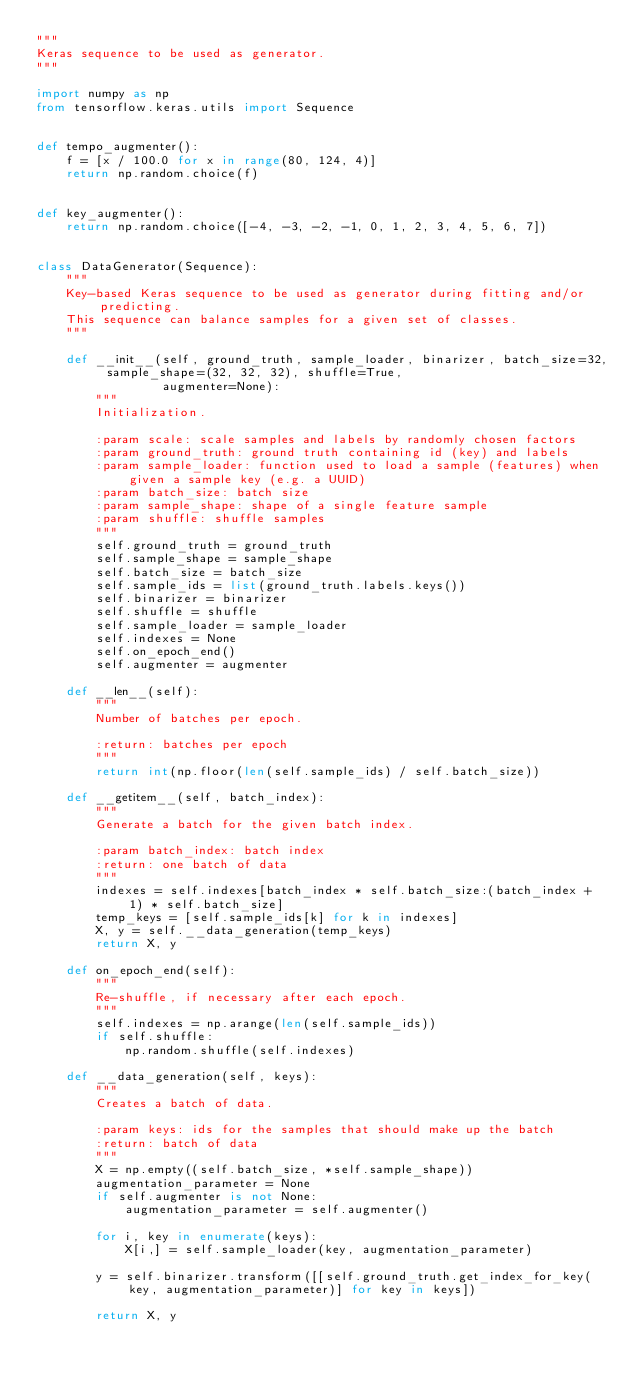<code> <loc_0><loc_0><loc_500><loc_500><_Python_>"""
Keras sequence to be used as generator.
"""

import numpy as np
from tensorflow.keras.utils import Sequence


def tempo_augmenter():
    f = [x / 100.0 for x in range(80, 124, 4)]
    return np.random.choice(f)


def key_augmenter():
    return np.random.choice([-4, -3, -2, -1, 0, 1, 2, 3, 4, 5, 6, 7])


class DataGenerator(Sequence):
    """
    Key-based Keras sequence to be used as generator during fitting and/or predicting.
    This sequence can balance samples for a given set of classes.
    """

    def __init__(self, ground_truth, sample_loader, binarizer, batch_size=32, sample_shape=(32, 32, 32), shuffle=True,
                 augmenter=None):
        """
        Initialization.

        :param scale: scale samples and labels by randomly chosen factors
        :param ground_truth: ground truth containing id (key) and labels
        :param sample_loader: function used to load a sample (features) when given a sample key (e.g. a UUID)
        :param batch_size: batch size
        :param sample_shape: shape of a single feature sample
        :param shuffle: shuffle samples
        """
        self.ground_truth = ground_truth
        self.sample_shape = sample_shape
        self.batch_size = batch_size
        self.sample_ids = list(ground_truth.labels.keys())
        self.binarizer = binarizer
        self.shuffle = shuffle
        self.sample_loader = sample_loader
        self.indexes = None
        self.on_epoch_end()
        self.augmenter = augmenter

    def __len__(self):
        """
        Number of batches per epoch.

        :return: batches per epoch
        """
        return int(np.floor(len(self.sample_ids) / self.batch_size))

    def __getitem__(self, batch_index):
        """
        Generate a batch for the given batch index.

        :param batch_index: batch index
        :return: one batch of data
        """
        indexes = self.indexes[batch_index * self.batch_size:(batch_index + 1) * self.batch_size]
        temp_keys = [self.sample_ids[k] for k in indexes]
        X, y = self.__data_generation(temp_keys)
        return X, y

    def on_epoch_end(self):
        """
        Re-shuffle, if necessary after each epoch.
        """
        self.indexes = np.arange(len(self.sample_ids))
        if self.shuffle:
            np.random.shuffle(self.indexes)

    def __data_generation(self, keys):
        """
        Creates a batch of data.

        :param keys: ids for the samples that should make up the batch
        :return: batch of data
        """
        X = np.empty((self.batch_size, *self.sample_shape))
        augmentation_parameter = None
        if self.augmenter is not None:
            augmentation_parameter = self.augmenter()

        for i, key in enumerate(keys):
            X[i,] = self.sample_loader(key, augmentation_parameter)

        y = self.binarizer.transform([[self.ground_truth.get_index_for_key(key, augmentation_parameter)] for key in keys])

        return X, y
</code> 